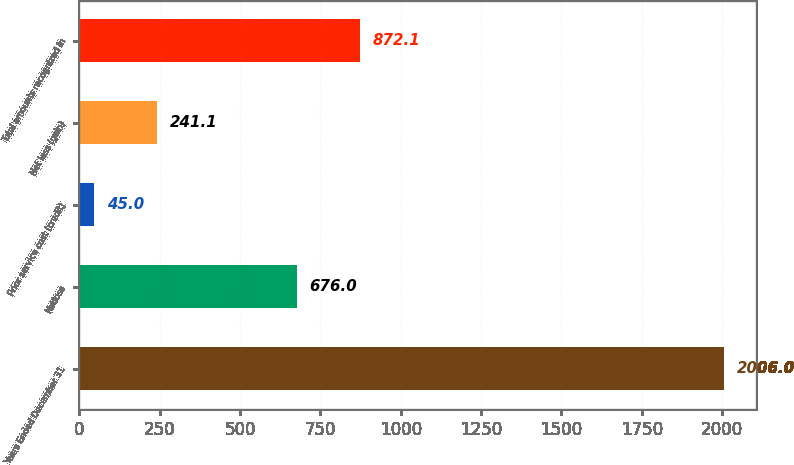Convert chart. <chart><loc_0><loc_0><loc_500><loc_500><bar_chart><fcel>Years Ended December 31<fcel>Netloss<fcel>Prior service cost (credit)<fcel>Net loss (gain)<fcel>Total amounts recognized in<nl><fcel>2006<fcel>676<fcel>45<fcel>241.1<fcel>872.1<nl></chart> 